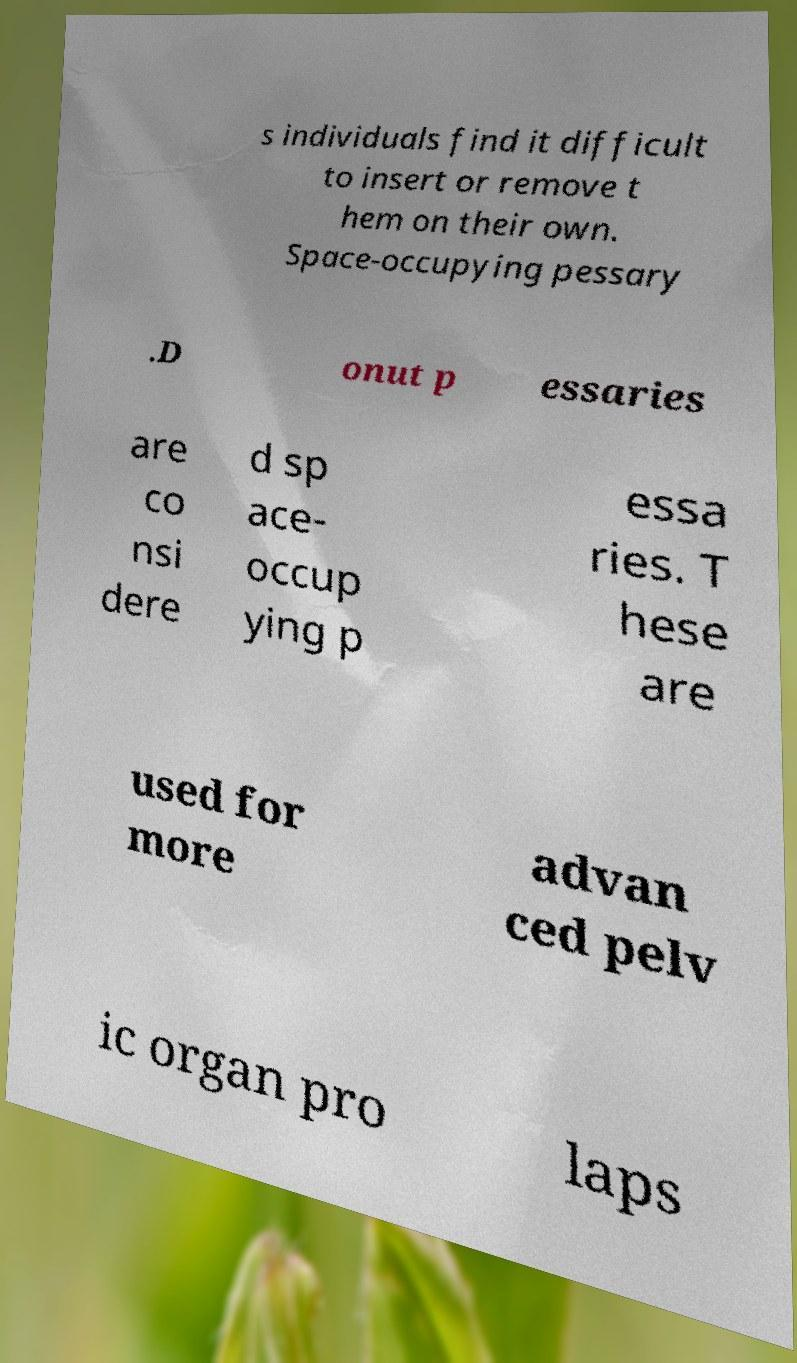For documentation purposes, I need the text within this image transcribed. Could you provide that? s individuals find it difficult to insert or remove t hem on their own. Space-occupying pessary .D onut p essaries are co nsi dere d sp ace- occup ying p essa ries. T hese are used for more advan ced pelv ic organ pro laps 